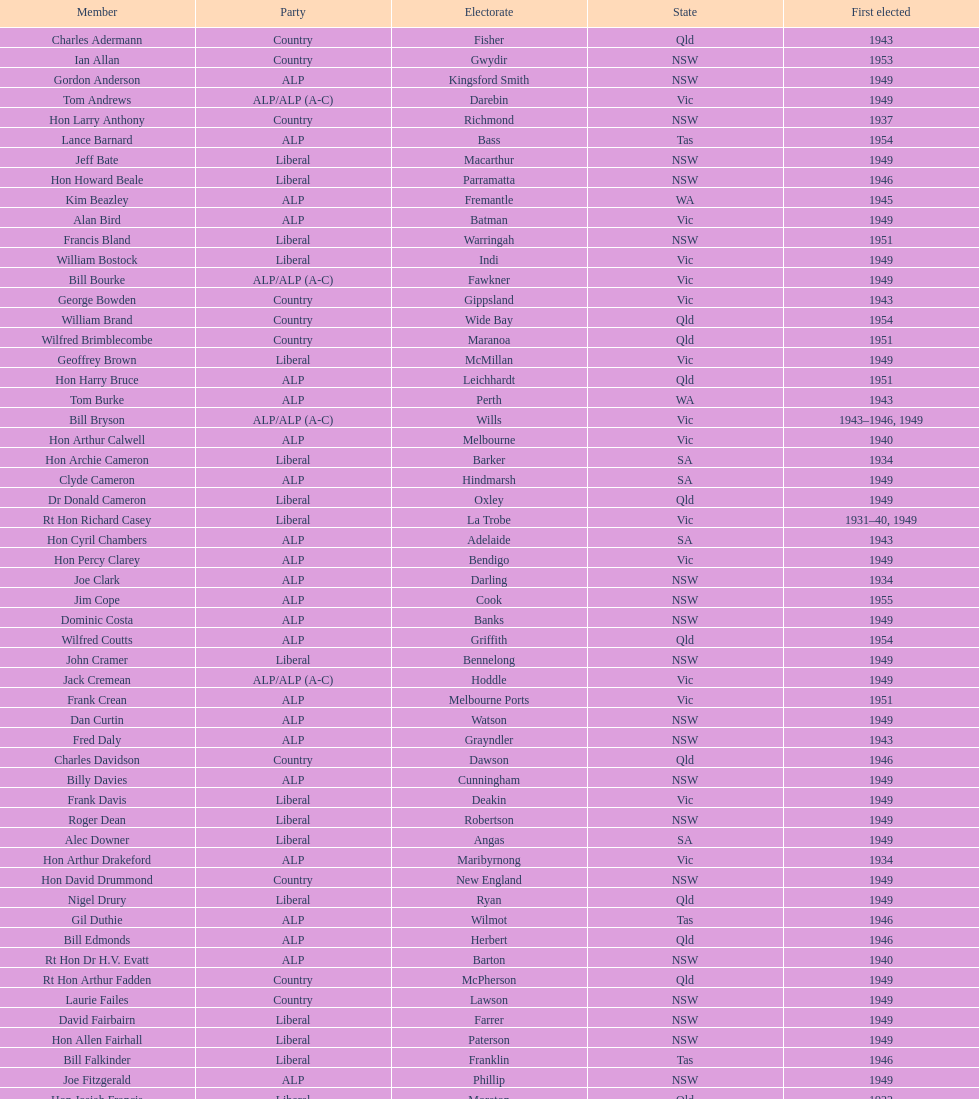When did joe clark get elected for the first time? 1934. Give me the full table as a dictionary. {'header': ['Member', 'Party', 'Electorate', 'State', 'First elected'], 'rows': [['Charles Adermann', 'Country', 'Fisher', 'Qld', '1943'], ['Ian Allan', 'Country', 'Gwydir', 'NSW', '1953'], ['Gordon Anderson', 'ALP', 'Kingsford Smith', 'NSW', '1949'], ['Tom Andrews', 'ALP/ALP (A-C)', 'Darebin', 'Vic', '1949'], ['Hon Larry Anthony', 'Country', 'Richmond', 'NSW', '1937'], ['Lance Barnard', 'ALP', 'Bass', 'Tas', '1954'], ['Jeff Bate', 'Liberal', 'Macarthur', 'NSW', '1949'], ['Hon Howard Beale', 'Liberal', 'Parramatta', 'NSW', '1946'], ['Kim Beazley', 'ALP', 'Fremantle', 'WA', '1945'], ['Alan Bird', 'ALP', 'Batman', 'Vic', '1949'], ['Francis Bland', 'Liberal', 'Warringah', 'NSW', '1951'], ['William Bostock', 'Liberal', 'Indi', 'Vic', '1949'], ['Bill Bourke', 'ALP/ALP (A-C)', 'Fawkner', 'Vic', '1949'], ['George Bowden', 'Country', 'Gippsland', 'Vic', '1943'], ['William Brand', 'Country', 'Wide Bay', 'Qld', '1954'], ['Wilfred Brimblecombe', 'Country', 'Maranoa', 'Qld', '1951'], ['Geoffrey Brown', 'Liberal', 'McMillan', 'Vic', '1949'], ['Hon Harry Bruce', 'ALP', 'Leichhardt', 'Qld', '1951'], ['Tom Burke', 'ALP', 'Perth', 'WA', '1943'], ['Bill Bryson', 'ALP/ALP (A-C)', 'Wills', 'Vic', '1943–1946, 1949'], ['Hon Arthur Calwell', 'ALP', 'Melbourne', 'Vic', '1940'], ['Hon Archie Cameron', 'Liberal', 'Barker', 'SA', '1934'], ['Clyde Cameron', 'ALP', 'Hindmarsh', 'SA', '1949'], ['Dr Donald Cameron', 'Liberal', 'Oxley', 'Qld', '1949'], ['Rt Hon Richard Casey', 'Liberal', 'La Trobe', 'Vic', '1931–40, 1949'], ['Hon Cyril Chambers', 'ALP', 'Adelaide', 'SA', '1943'], ['Hon Percy Clarey', 'ALP', 'Bendigo', 'Vic', '1949'], ['Joe Clark', 'ALP', 'Darling', 'NSW', '1934'], ['Jim Cope', 'ALP', 'Cook', 'NSW', '1955'], ['Dominic Costa', 'ALP', 'Banks', 'NSW', '1949'], ['Wilfred Coutts', 'ALP', 'Griffith', 'Qld', '1954'], ['John Cramer', 'Liberal', 'Bennelong', 'NSW', '1949'], ['Jack Cremean', 'ALP/ALP (A-C)', 'Hoddle', 'Vic', '1949'], ['Frank Crean', 'ALP', 'Melbourne Ports', 'Vic', '1951'], ['Dan Curtin', 'ALP', 'Watson', 'NSW', '1949'], ['Fred Daly', 'ALP', 'Grayndler', 'NSW', '1943'], ['Charles Davidson', 'Country', 'Dawson', 'Qld', '1946'], ['Billy Davies', 'ALP', 'Cunningham', 'NSW', '1949'], ['Frank Davis', 'Liberal', 'Deakin', 'Vic', '1949'], ['Roger Dean', 'Liberal', 'Robertson', 'NSW', '1949'], ['Alec Downer', 'Liberal', 'Angas', 'SA', '1949'], ['Hon Arthur Drakeford', 'ALP', 'Maribyrnong', 'Vic', '1934'], ['Hon David Drummond', 'Country', 'New England', 'NSW', '1949'], ['Nigel Drury', 'Liberal', 'Ryan', 'Qld', '1949'], ['Gil Duthie', 'ALP', 'Wilmot', 'Tas', '1946'], ['Bill Edmonds', 'ALP', 'Herbert', 'Qld', '1946'], ['Rt Hon Dr H.V. Evatt', 'ALP', 'Barton', 'NSW', '1940'], ['Rt Hon Arthur Fadden', 'Country', 'McPherson', 'Qld', '1949'], ['Laurie Failes', 'Country', 'Lawson', 'NSW', '1949'], ['David Fairbairn', 'Liberal', 'Farrer', 'NSW', '1949'], ['Hon Allen Fairhall', 'Liberal', 'Paterson', 'NSW', '1949'], ['Bill Falkinder', 'Liberal', 'Franklin', 'Tas', '1946'], ['Joe Fitzgerald', 'ALP', 'Phillip', 'NSW', '1949'], ['Hon Josiah Francis', 'Liberal', 'Moreton', 'Qld', '1922'], ['Allan Fraser', 'ALP', 'Eden-Monaro', 'NSW', '1943'], ['Jim Fraser', 'ALP', 'Australian Capital Territory', 'ACT', '1951'], ['Gordon Freeth', 'Liberal', 'Forrest', 'WA', '1949'], ['Arthur Fuller', 'Country', 'Hume', 'NSW', '1943–49, 1951'], ['Pat Galvin', 'ALP', 'Kingston', 'SA', '1951'], ['Arthur Greenup', 'ALP', 'Dalley', 'NSW', '1953'], ['Charles Griffiths', 'ALP', 'Shortland', 'NSW', '1949'], ['Jo Gullett', 'Liberal', 'Henty', 'Vic', '1946'], ['Len Hamilton', 'Country', 'Canning', 'WA', '1946'], ['Rt Hon Eric Harrison', 'Liberal', 'Wentworth', 'NSW', '1931'], ['Jim Harrison', 'ALP', 'Blaxland', 'NSW', '1949'], ['Hon Paul Hasluck', 'Liberal', 'Curtin', 'WA', '1949'], ['Hon William Haworth', 'Liberal', 'Isaacs', 'Vic', '1949'], ['Leslie Haylen', 'ALP', 'Parkes', 'NSW', '1943'], ['Rt Hon Harold Holt', 'Liberal', 'Higgins', 'Vic', '1935'], ['John Howse', 'Liberal', 'Calare', 'NSW', '1946'], ['Alan Hulme', 'Liberal', 'Petrie', 'Qld', '1949'], ['William Jack', 'Liberal', 'North Sydney', 'NSW', '1949'], ['Rowley James', 'ALP', 'Hunter', 'NSW', '1928'], ['Hon Herbert Johnson', 'ALP', 'Kalgoorlie', 'WA', '1940'], ['Bob Joshua', 'ALP/ALP (A-C)', 'Ballaarat', 'ALP', '1951'], ['Percy Joske', 'Liberal', 'Balaclava', 'Vic', '1951'], ['Hon Wilfrid Kent Hughes', 'Liberal', 'Chisholm', 'Vic', '1949'], ['Stan Keon', 'ALP/ALP (A-C)', 'Yarra', 'Vic', '1949'], ['William Lawrence', 'Liberal', 'Wimmera', 'Vic', '1949'], ['Hon George Lawson', 'ALP', 'Brisbane', 'Qld', '1931'], ['Nelson Lemmon', 'ALP', 'St George', 'NSW', '1943–49, 1954'], ['Hugh Leslie', 'Liberal', 'Moore', 'Country', '1949'], ['Robert Lindsay', 'Liberal', 'Flinders', 'Vic', '1954'], ['Tony Luchetti', 'ALP', 'Macquarie', 'NSW', '1951'], ['Aubrey Luck', 'Liberal', 'Darwin', 'Tas', '1951'], ['Philip Lucock', 'Country', 'Lyne', 'NSW', '1953'], ['Dan Mackinnon', 'Liberal', 'Corangamite', 'Vic', '1949–51, 1953'], ['Hon Norman Makin', 'ALP', 'Sturt', 'SA', '1919–46, 1954'], ['Hon Philip McBride', 'Liberal', 'Wakefield', 'SA', '1931–37, 1937–43 (S), 1946'], ['Malcolm McColm', 'Liberal', 'Bowman', 'Qld', '1949'], ['Rt Hon John McEwen', 'Country', 'Murray', 'Vic', '1934'], ['John McLeay', 'Liberal', 'Boothby', 'SA', '1949'], ['Don McLeod', 'Liberal', 'Wannon', 'ALP', '1940–49, 1951'], ['Hon William McMahon', 'Liberal', 'Lowe', 'NSW', '1949'], ['Rt Hon Robert Menzies', 'Liberal', 'Kooyong', 'Vic', '1934'], ['Dan Minogue', 'ALP', 'West Sydney', 'NSW', '1949'], ['Charles Morgan', 'ALP', 'Reid', 'NSW', '1940–46, 1949'], ['Jack Mullens', 'ALP/ALP (A-C)', 'Gellibrand', 'Vic', '1949'], ['Jock Nelson', 'ALP', 'Northern Territory', 'NT', '1949'], ["William O'Connor", 'ALP', 'Martin', 'NSW', '1946'], ['Hubert Opperman', 'Liberal', 'Corio', 'Vic', '1949'], ['Hon Frederick Osborne', 'Liberal', 'Evans', 'NSW', '1949'], ['Rt Hon Sir Earle Page', 'Country', 'Cowper', 'NSW', '1919'], ['Henry Pearce', 'Liberal', 'Capricornia', 'Qld', '1949'], ['Ted Peters', 'ALP', 'Burke', 'Vic', '1949'], ['Hon Reg Pollard', 'ALP', 'Lalor', 'Vic', '1937'], ['Hon Bill Riordan', 'ALP', 'Kennedy', 'Qld', '1936'], ['Hugh Roberton', 'Country', 'Riverina', 'NSW', '1949'], ['Edgar Russell', 'ALP', 'Grey', 'SA', '1943'], ['Tom Sheehan', 'ALP', 'Cook', 'NSW', '1937'], ['Frank Stewart', 'ALP', 'Lang', 'NSW', '1953'], ['Reginald Swartz', 'Liberal', 'Darling Downs', 'Qld', '1949'], ['Albert Thompson', 'ALP', 'Port Adelaide', 'SA', '1946'], ['Frank Timson', 'Liberal', 'Higinbotham', 'Vic', '1949'], ['Hon Athol Townley', 'Liberal', 'Denison', 'Tas', '1949'], ['Winton Turnbull', 'Country', 'Mallee', 'Vic', '1946'], ['Harry Turner', 'Liberal', 'Bradfield', 'NSW', '1952'], ['Hon Eddie Ward', 'ALP', 'East Sydney', 'NSW', '1931, 1932'], ['David Oliver Watkins', 'ALP', 'Newcastle', 'NSW', '1935'], ['Harry Webb', 'ALP', 'Swan', 'WA', '1954'], ['William Wentworth', 'Liberal', 'Mackellar', 'NSW', '1949'], ['Roy Wheeler', 'Liberal', 'Mitchell', 'NSW', '1949'], ['Gough Whitlam', 'ALP', 'Werriwa', 'NSW', '1952'], ['Bruce Wight', 'Liberal', 'Lilley', 'Qld', '1949']]} 